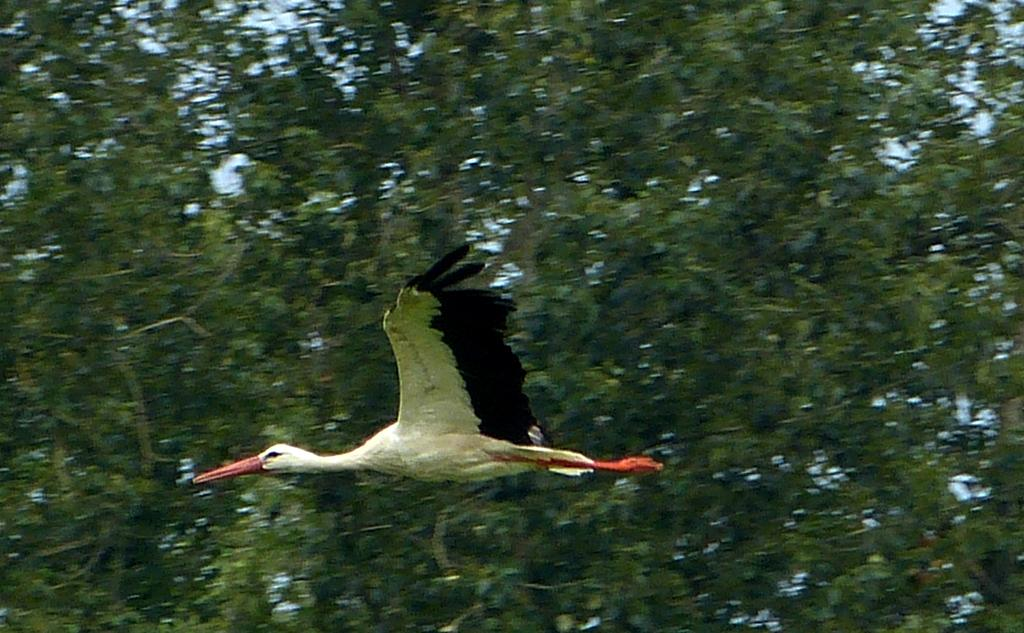What is the main subject of the image? The main subject of the image is a bird flying. What can be seen in the background of the image? There are trees visible in the image. What else is visible in the image besides the bird and trees? The sky is visible in the image. What is the queen's wealth in the image? There is no queen or mention of wealth in the image; it features a bird flying in front of trees and the sky. 